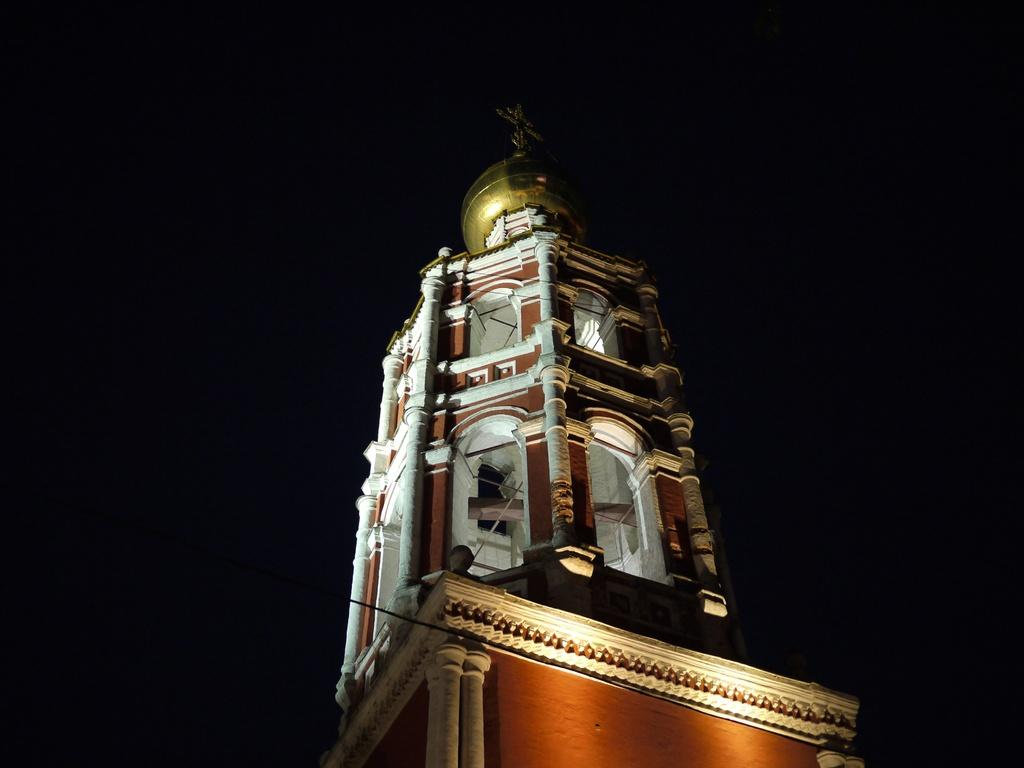What is the main subject of the image? The main subject of the image is a building. Can you describe the background of the image? The background of the image is dark. How many lizards can be seen climbing on the building in the image? There are no lizards present in the image; it only features a building with a dark background. 